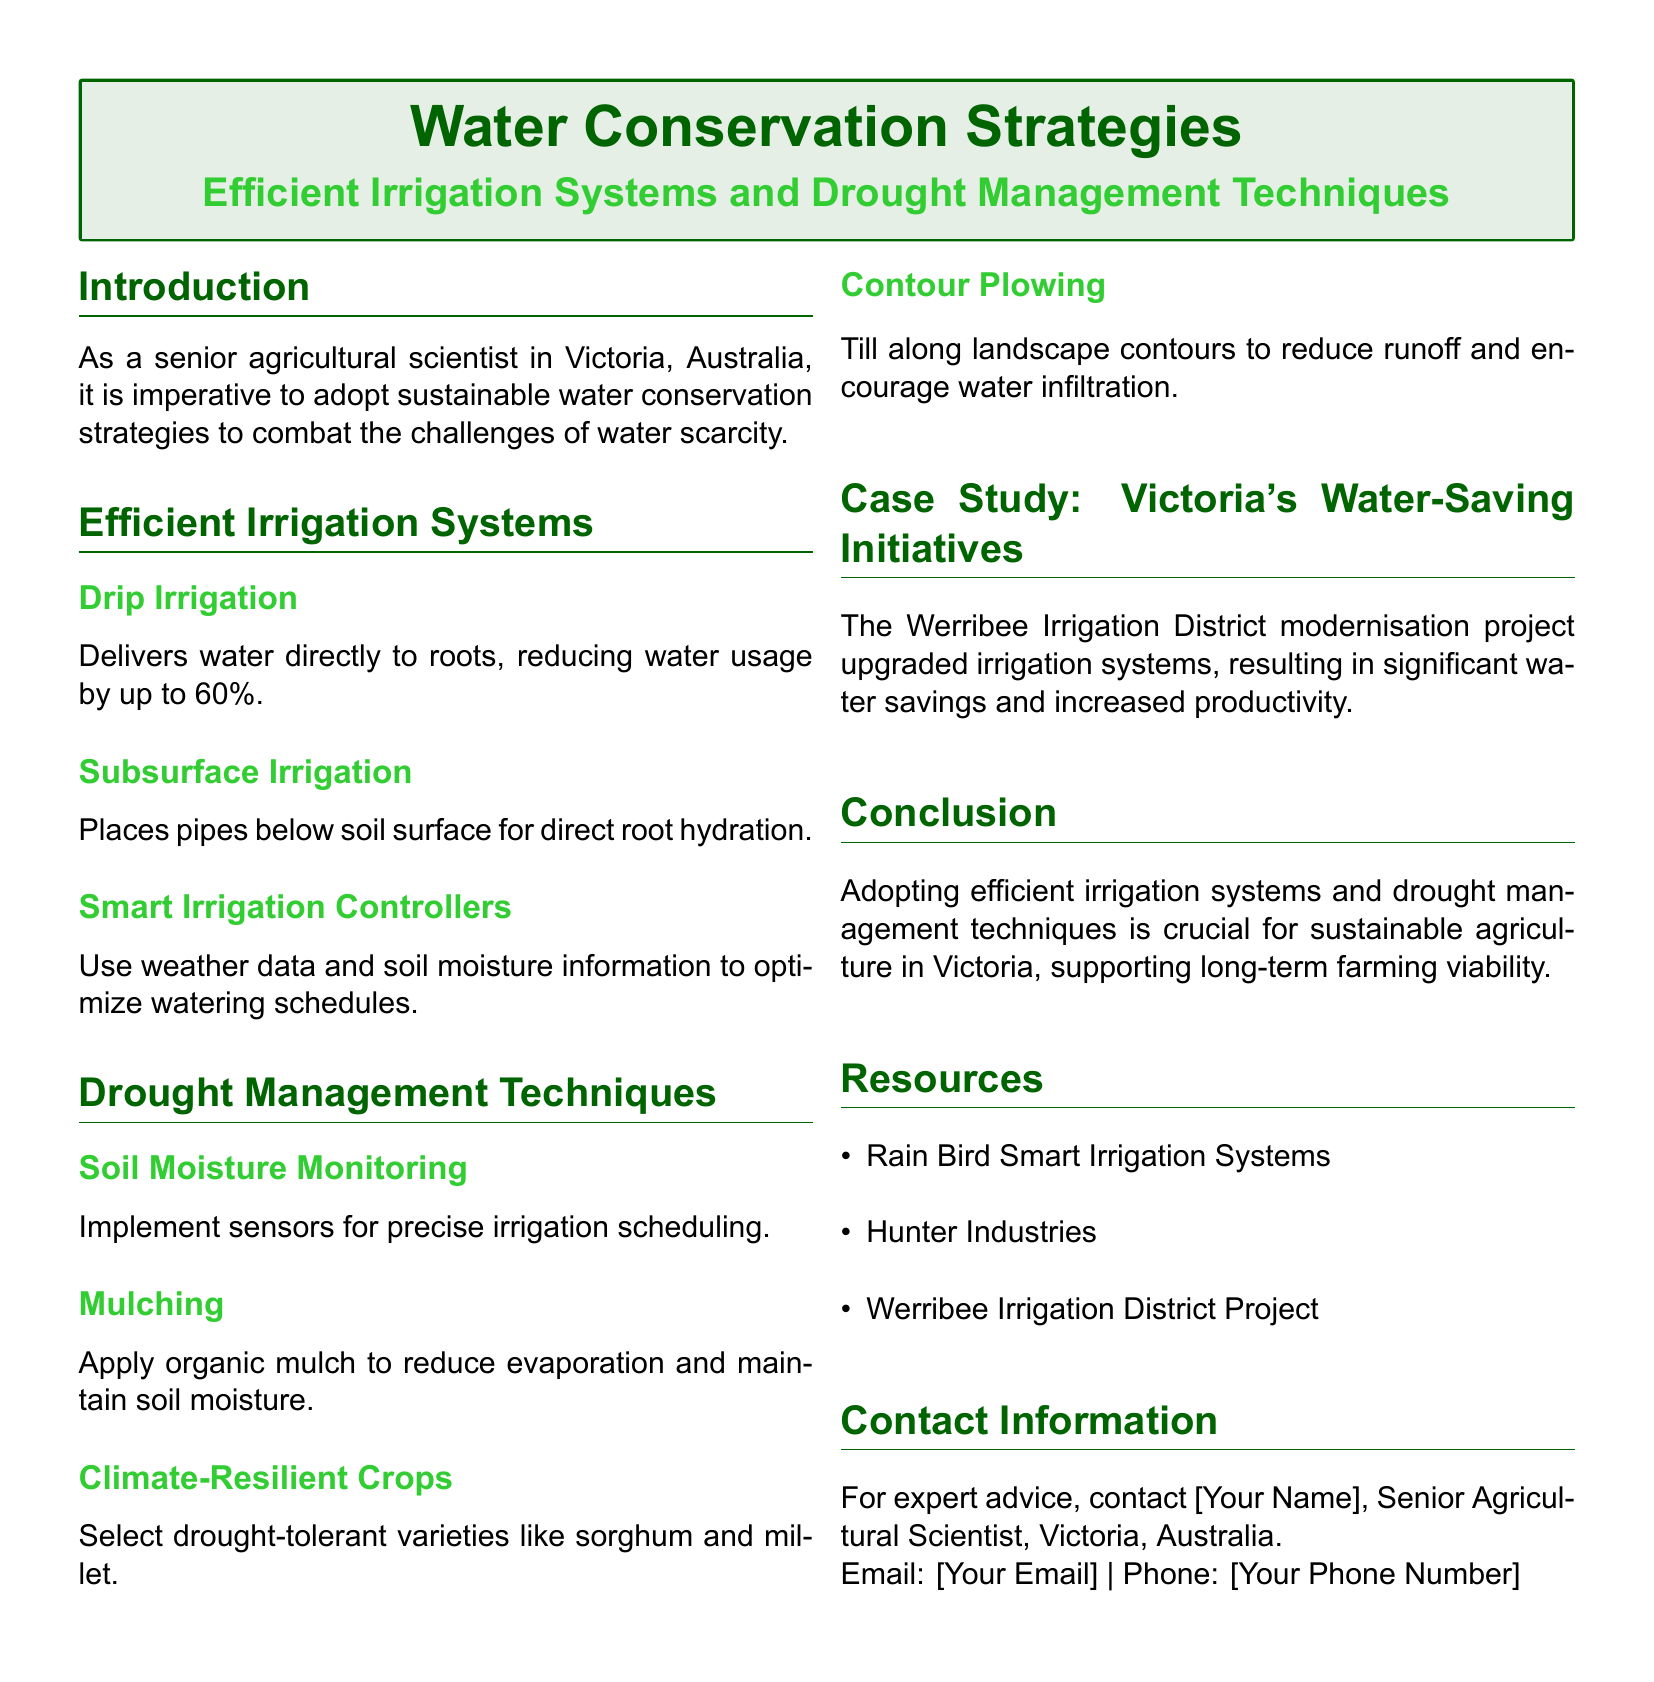What is the main focus of the flyer? The main focus is on sustainable water conservation strategies, specifically efficient irrigation systems and drought management techniques.
Answer: Sustainable water conservation strategies What reduction in water usage can drip irrigation achieve? Drip irrigation can reduce water usage by up to 60 percent, as stated in the document.
Answer: 60% What are two examples of drought management techniques mentioned? Two examples provided are soil moisture monitoring and mulching.
Answer: Soil moisture monitoring, mulching Which crop varieties are suggested as climate-resilient? The document suggests selecting drought-tolerant varieties like sorghum and millet.
Answer: Sorghum and millet What is stated about the Werribee Irrigation District project? The project modernized irrigation systems, which resulted in significant water savings and increased productivity.
Answer: Significant water savings and increased productivity How does a smart irrigation controller optimize watering? It uses weather data and soil moisture information to optimize irrigation schedules.
Answer: Weather data and soil moisture information What is the purpose of applying organic mulch? Organic mulch is applied to reduce evaporation and maintain soil moisture.
Answer: Reduce evaporation and maintain soil moisture What type of plowing is recommended for reducing runoff? Contour plowing is recommended to reduce runoff and encourage water infiltration.
Answer: Contour plowing 